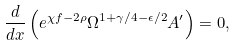Convert formula to latex. <formula><loc_0><loc_0><loc_500><loc_500>\frac { d } { d x } \left ( e ^ { \chi f - 2 \rho } \Omega ^ { 1 + \gamma / 4 - \epsilon / 2 } A ^ { \prime } \right ) = 0 ,</formula> 